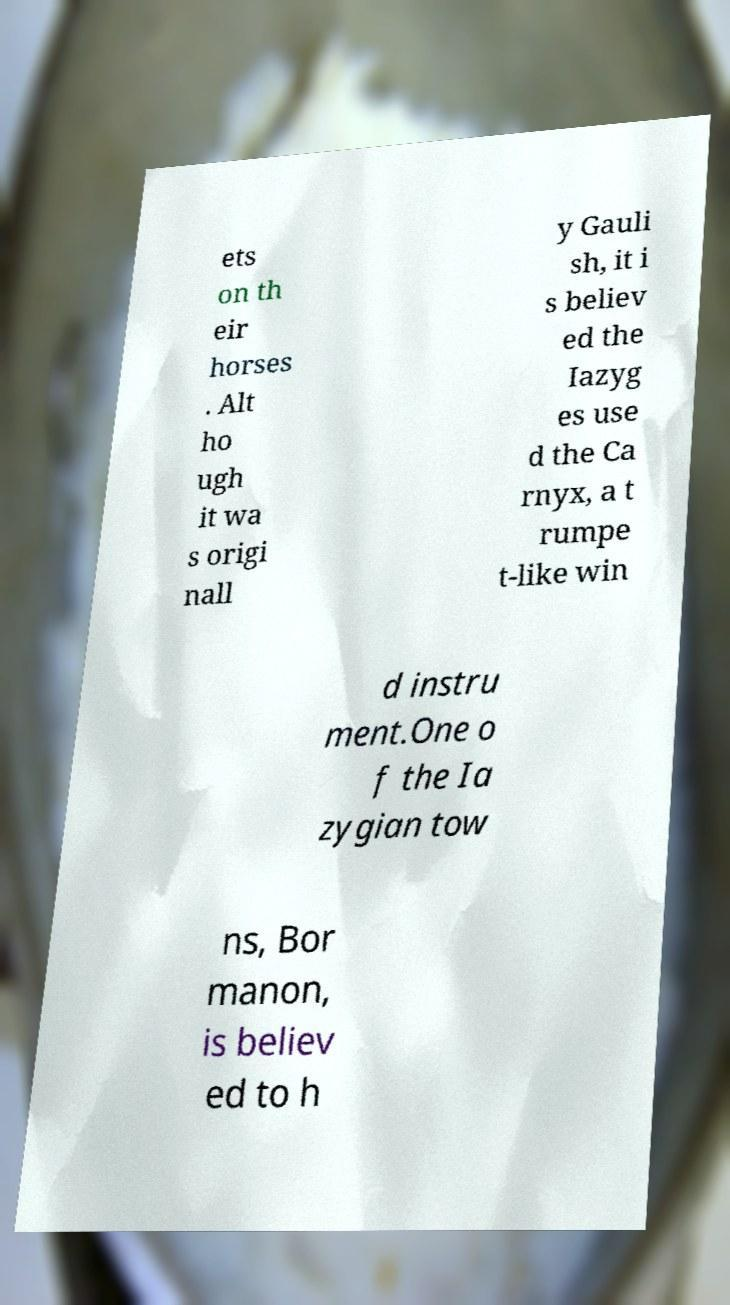Could you assist in decoding the text presented in this image and type it out clearly? ets on th eir horses . Alt ho ugh it wa s origi nall y Gauli sh, it i s believ ed the Iazyg es use d the Ca rnyx, a t rumpe t-like win d instru ment.One o f the Ia zygian tow ns, Bor manon, is believ ed to h 